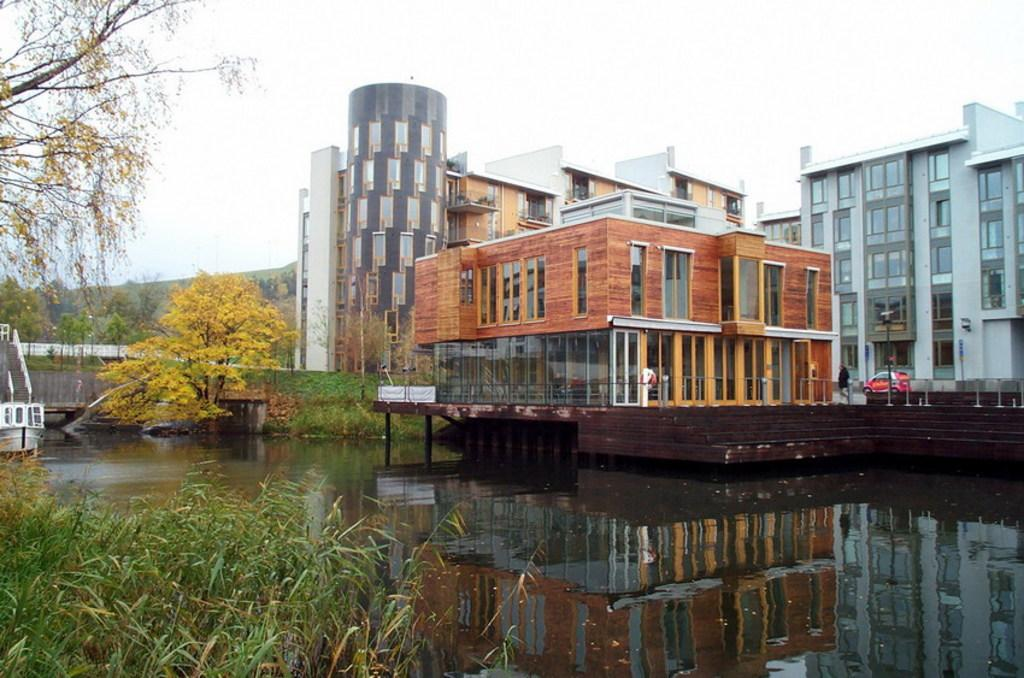What type of structures can be seen in the image? There are buildings in the image. Can you describe the person in the image? There is a person in the image. What mode of transportation is present in the image? There is a vehicle in the image. What type of pathway is visible in the image? There is a road in the image. What are the tall, slender objects in the image? There are poles in the image. What type of vegetation is present in the image? There are trees in the image. What natural feature can be seen in the image? A: There is water visible in the image. What type of watercraft is present in the image? There is a boat in the image. What type of man-made structure connects two points in the image? There is a bridge in the image. What type of elevated landform is present in the image? There is a hill in the image. What can be seen above the land and water in the image? The sky is visible in the image. How many balls are bouncing on the hill in the image? There are no balls present in the image, so it is not possible to determine how many would be bouncing on the hill. 